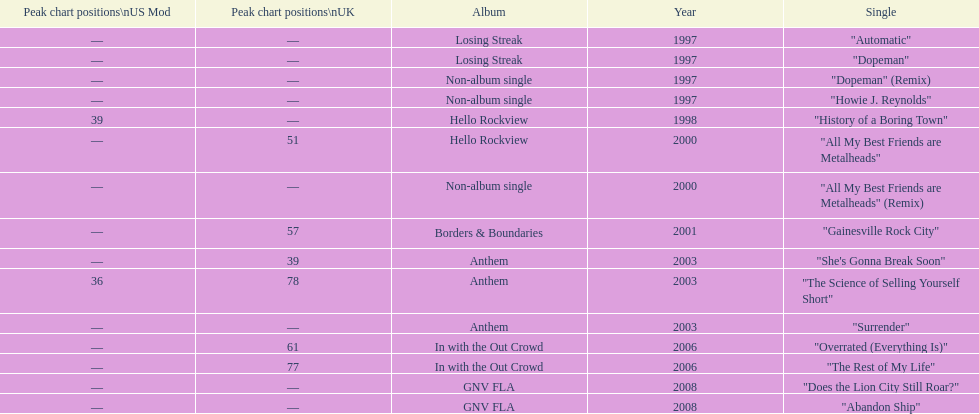Which song came out first? dopeman or surrender. Dopeman. 